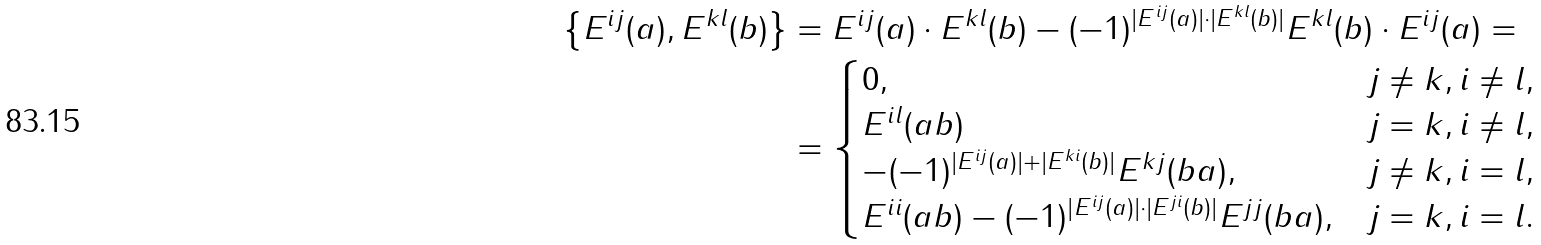<formula> <loc_0><loc_0><loc_500><loc_500>\left \{ E ^ { i j } ( a ) , E ^ { k l } ( b ) \right \} & = E ^ { i j } ( a ) \cdot E ^ { k l } ( b ) - ( - 1 ) ^ { | E ^ { i j } ( a ) | \cdot | E ^ { k l } ( b ) | } E ^ { k l } ( b ) \cdot E ^ { i j } ( a ) = \\ & = \begin{cases} 0 , & j \neq k , i \neq l , \\ E ^ { i l } ( a b ) & j = k , i \neq l , \\ - ( - 1 ) ^ { | E ^ { i j } ( a ) | + | E ^ { k i } ( b ) | } E ^ { k j } ( b a ) , & j \neq k , i = l , \\ E ^ { i i } ( a b ) - ( - 1 ) ^ { | E ^ { i j } ( a ) | \cdot | E ^ { j i } ( b ) | } E ^ { j j } ( b a ) , & j = k , i = l . \end{cases}</formula> 